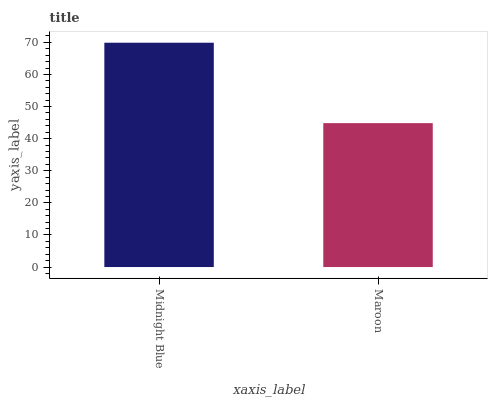Is Maroon the minimum?
Answer yes or no. Yes. Is Midnight Blue the maximum?
Answer yes or no. Yes. Is Maroon the maximum?
Answer yes or no. No. Is Midnight Blue greater than Maroon?
Answer yes or no. Yes. Is Maroon less than Midnight Blue?
Answer yes or no. Yes. Is Maroon greater than Midnight Blue?
Answer yes or no. No. Is Midnight Blue less than Maroon?
Answer yes or no. No. Is Midnight Blue the high median?
Answer yes or no. Yes. Is Maroon the low median?
Answer yes or no. Yes. Is Maroon the high median?
Answer yes or no. No. Is Midnight Blue the low median?
Answer yes or no. No. 